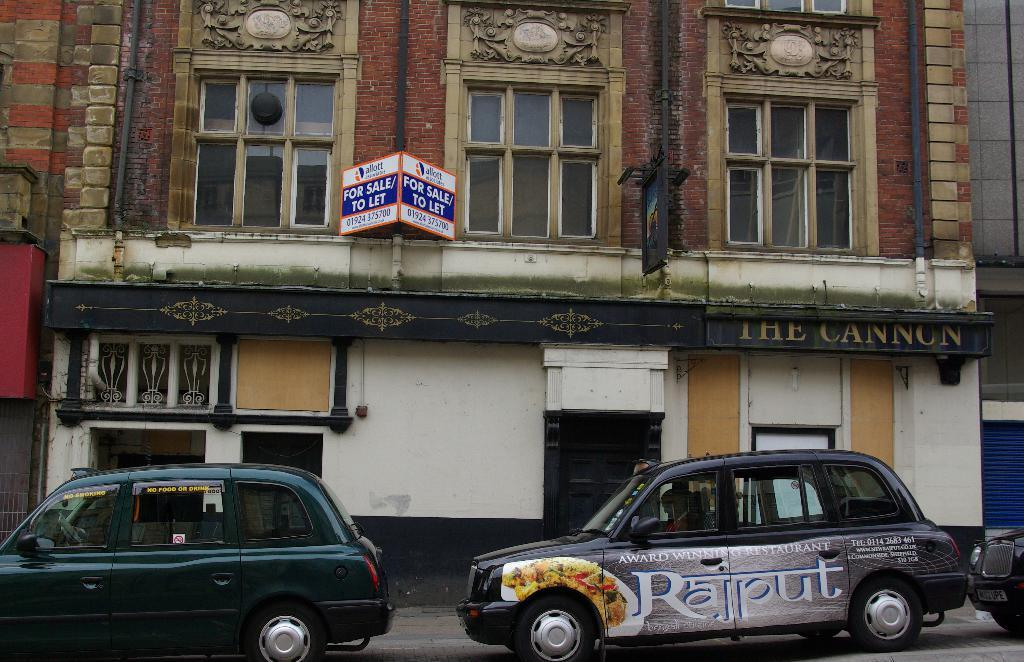Provide a one-sentence caption for the provided image. a car that has the letter R on the front of it. 